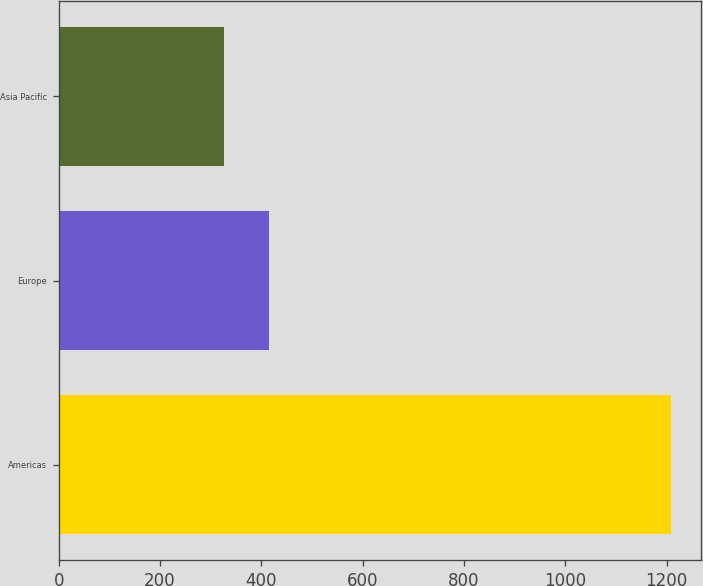Convert chart. <chart><loc_0><loc_0><loc_500><loc_500><bar_chart><fcel>Americas<fcel>Europe<fcel>Asia Pacific<nl><fcel>1208.3<fcel>414.86<fcel>326.7<nl></chart> 